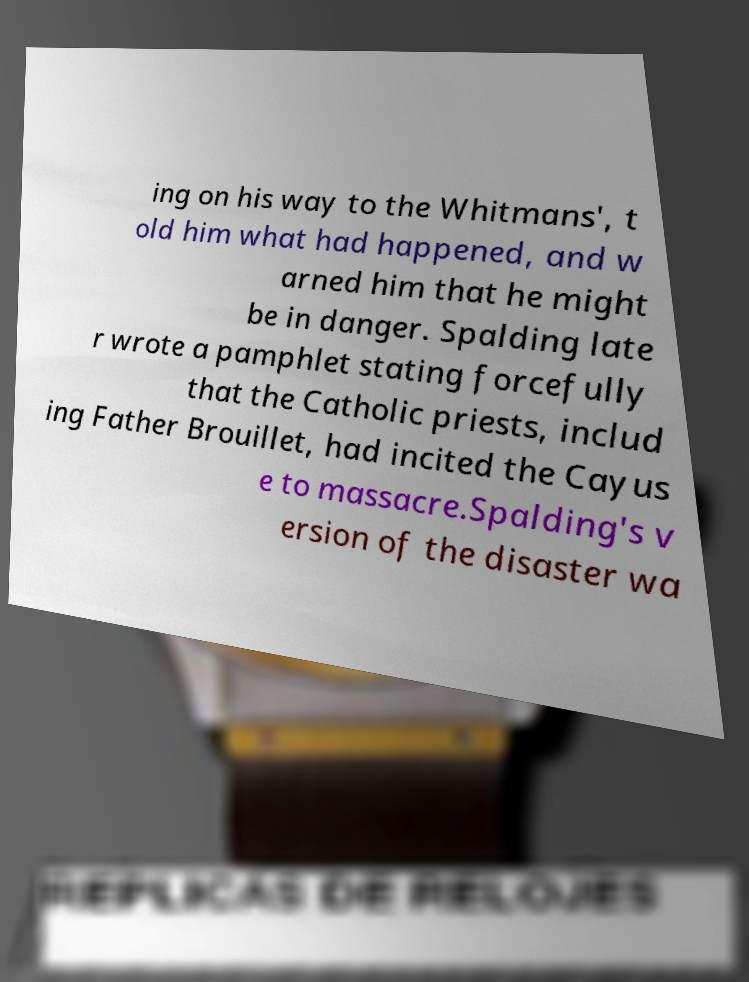I need the written content from this picture converted into text. Can you do that? ing on his way to the Whitmans', t old him what had happened, and w arned him that he might be in danger. Spalding late r wrote a pamphlet stating forcefully that the Catholic priests, includ ing Father Brouillet, had incited the Cayus e to massacre.Spalding's v ersion of the disaster wa 